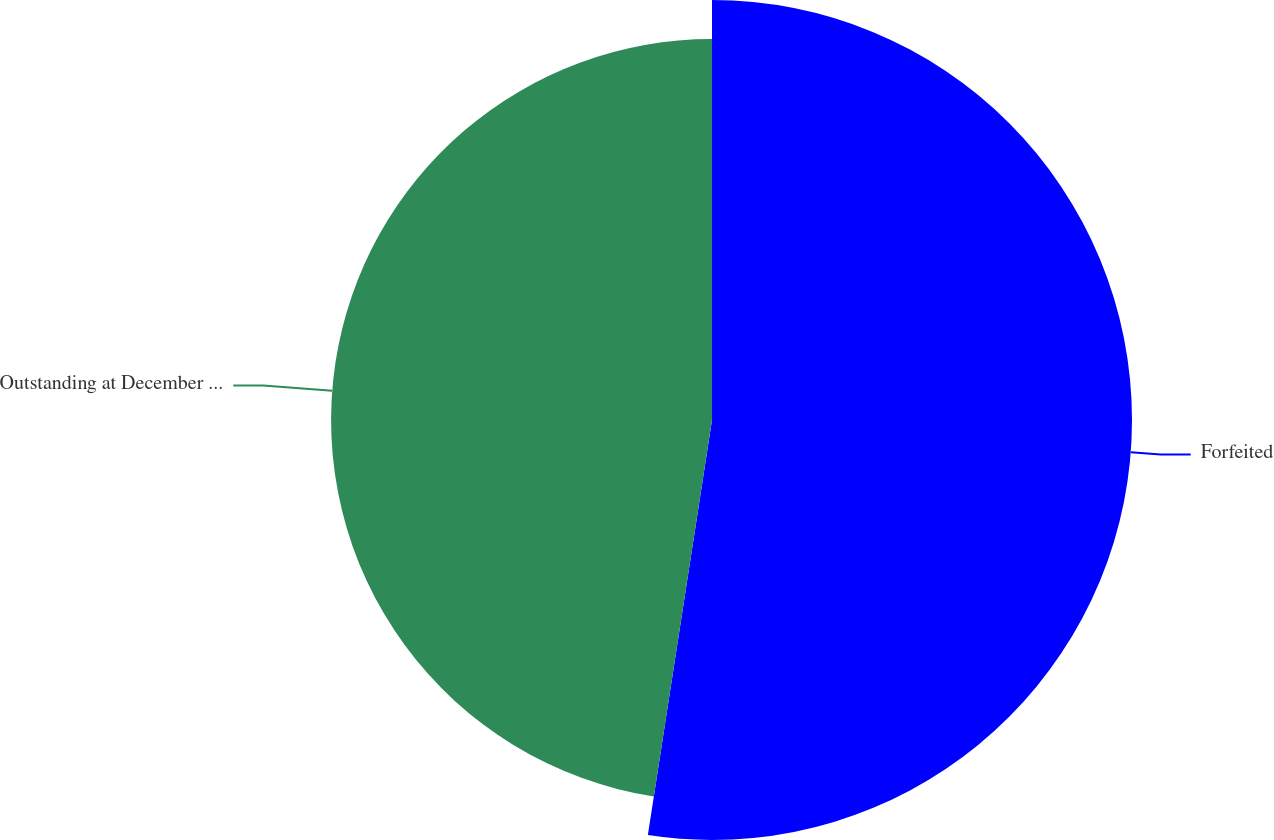Convert chart to OTSL. <chart><loc_0><loc_0><loc_500><loc_500><pie_chart><fcel>Forfeited<fcel>Outstanding at December 31<nl><fcel>52.44%<fcel>47.56%<nl></chart> 